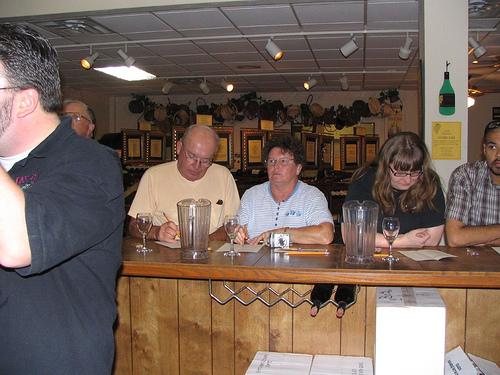Are these people talking to each other?
Give a very brief answer. No. How many people are looking down?
Answer briefly. 2. Where is the wine stored?
Answer briefly. Under counter. 